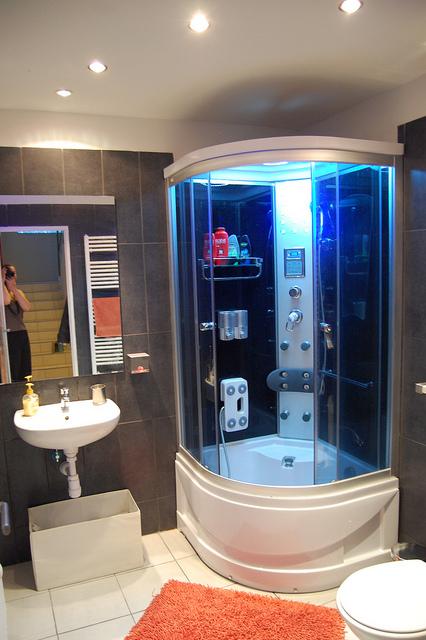On what side of the photo can the photographer be seen?
Write a very short answer. Left. What color is the bath mat?
Be succinct. Orange. How many bath products are on the top rack in the shower?
Keep it brief. 3. 